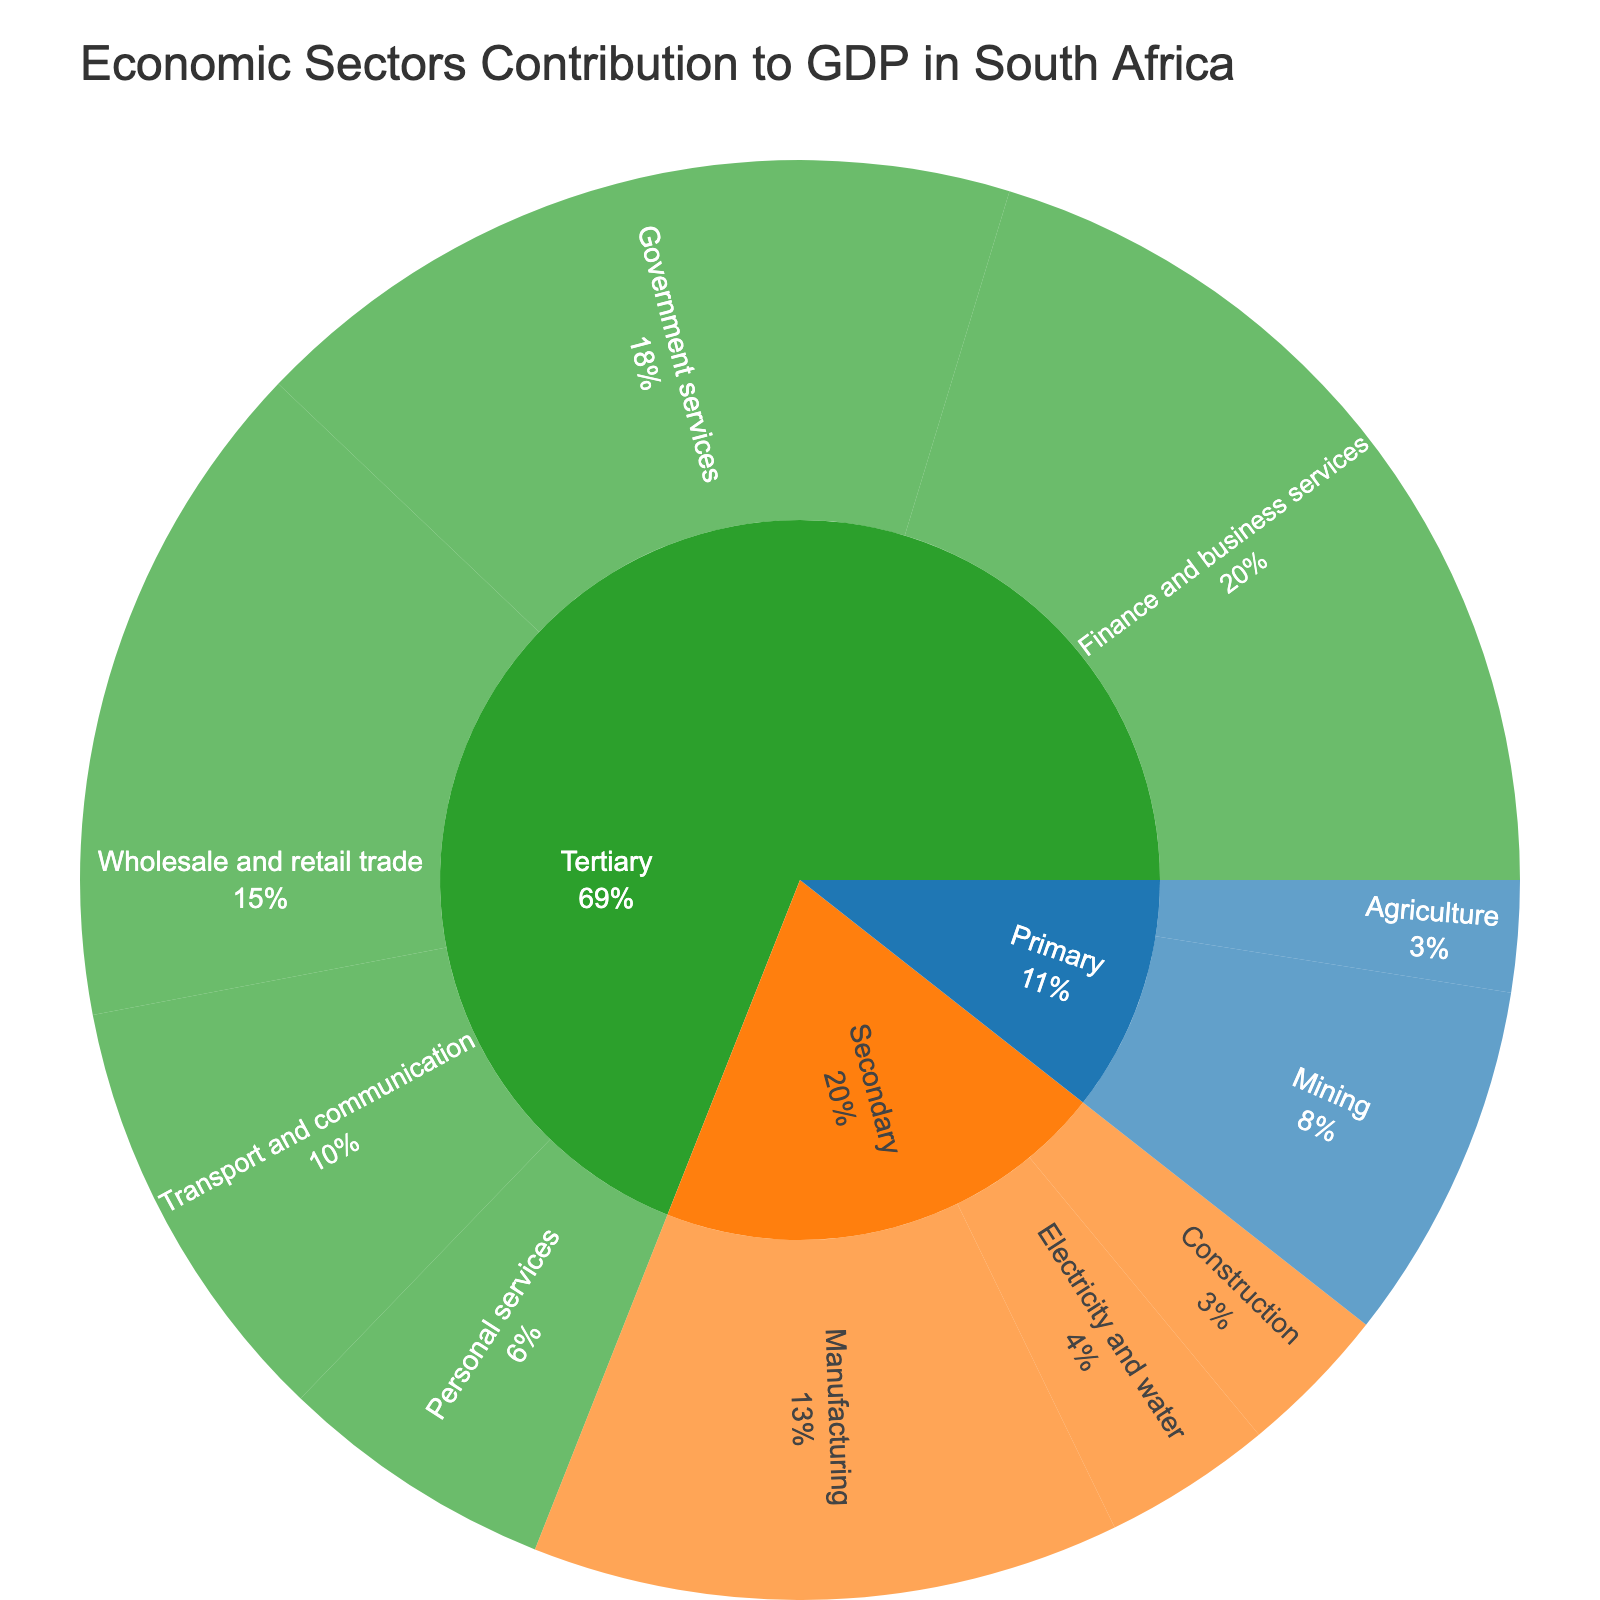what are the main sectors contributing to GDP in South Africa? The figure shows the sunburst plot with sectors divided into three main categories: Primary, Secondary, and Tertiary, visible in the plot.
Answer: Primary, Secondary, Tertiary Which industry has the highest contribution among the sectors? From visual inspection, the industry with the largest segment within the Tertiary sector is Finance and business services, with 20.3%.
Answer: Finance and business services What is the combined GDP contribution of the Primary sector? The Primary sector consists of Agriculture and Mining, contributing 2.5% and 8.1% respectively. Adding these contributions gives 2.5% + 8.1% = 10.6%.
Answer: 10.6% Compare the GDP contributions of the Manufacturing and Government services industries. The contributions are visualized in the plot. Manufacturing contributes 13.2%, whereas Government services contribute 17.6%. Thus, Government services contribute 4.4% more than Manufacturing.
Answer: Government services contribute 4.4% more than Manufacturing Which sector has the most diverse range of industries? The Tertiary sector possesses the widest array of industries in the sunburst plot, encompassing Wholesale and retail trade, Transport and communication, Finance and business services, Government services, and Personal services.
Answer: Tertiary What percentage of the GDP is contributed by the Tertiary sector? Summing up the contributions of the Tertiary sector industries gives: 15.1% (Wholesale and retail trade) + 9.8% (Transport and communication) + 20.3% (Finance and business services) + 17.6% (Government services) + 6.2% (Personal services) = 69.0%.
Answer: 69.0% How much more does the Wholesale and retail trade industry contribute to GDP compared to Construction? Wholesale and retail trade contributes 15.1%, whereas Construction contributes 3.4%. The difference is 15.1% - 3.4% = 11.7%.
Answer: 11.7% Identify the smallest contributing industry within the Secondary sector. Within the Secondary sector, the sunburst plot reveals three industries: Manufacturing (13.2%), Construction (3.4%), and Electricity and water (3.8%). Construction has the smallest contribution.
Answer: Construction What is the total contribution of all industries excluding the Tertiary sector? For this, sum the Primary and Secondary sector contributions: (2.5% + 8.1%) + (13.2% + 3.4% + 3.8%) = 10.6% + 20.4% = 31.0%.
Answer: 31.0% What proportion of the GDP does the Finance and business services industry contribute within the Tertiary sector? To determine this, divide the contribution of Finance and business services (20.3%) by the total Tertiary sector contribution (69.0%), resulting in (20.3 / 69.0) * 100 ≈ 29.4%.
Answer: 29.4% 